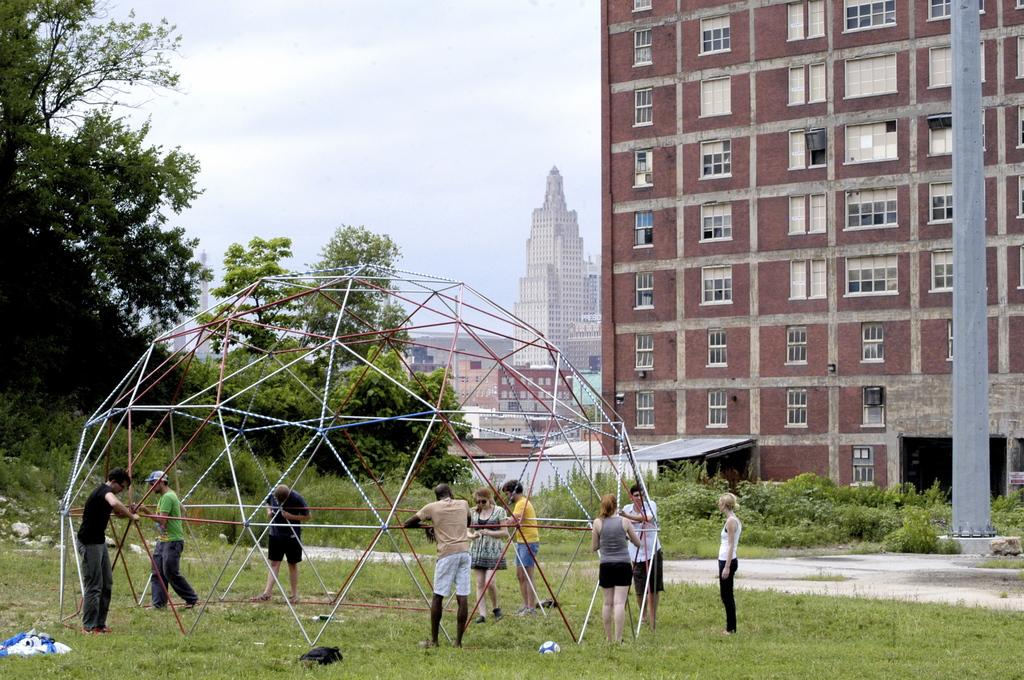What can be seen in the image? There are people standing in the image, along with rods, a dome, a ball, clothes on the grass, buildings, trees, grass, plants, and a pole in the background. The sky is also visible in the background. What are the people in the image doing? The provided facts do not specify what the people are doing, so we cannot definitively answer this question. What is the purpose of the rods in the image? The provided facts do not specify the purpose of the rods, so we cannot definitively answer this question. What type of dome is present in the image? The provided facts do not specify the type of dome, so we cannot definitively answer this question. What color are the clothes on the grass in the image? The provided facts do not specify the color of the clothes, so we cannot definitively answer this question. What can be seen in the background of the image? In the background of the image, there are buildings, trees, grass, plants, a pole, and the sky. What type of dress is the porter wearing in the image? There is no porter present in the image, so we cannot answer this question. How many soldiers are in the army depicted in the image? There is no army or soldiers present in the image, so we cannot answer this question. 